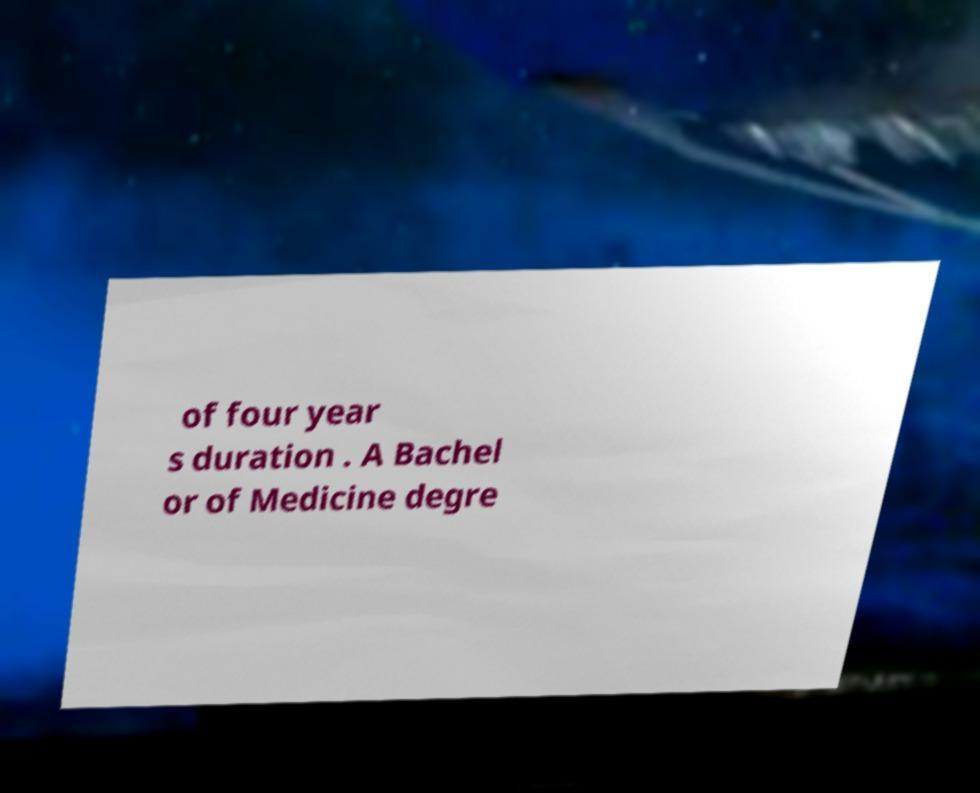Can you read and provide the text displayed in the image?This photo seems to have some interesting text. Can you extract and type it out for me? of four year s duration . A Bachel or of Medicine degre 